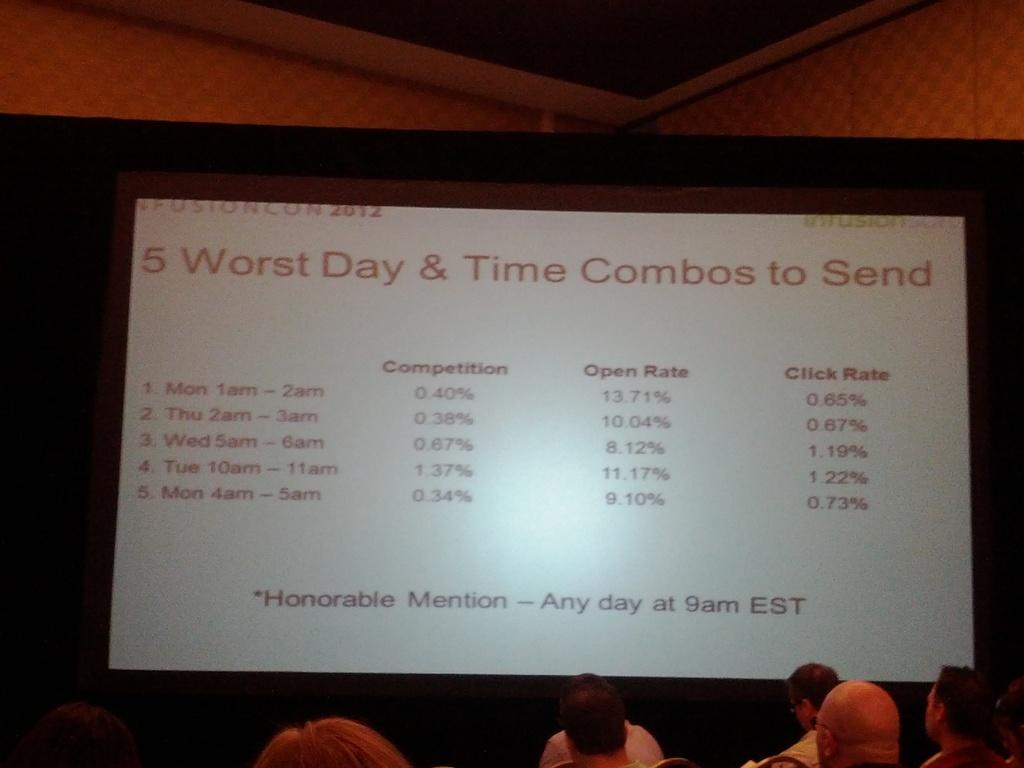What are the people in the image doing? The people in the image are sitting. What can be seen on the screen in the background of the image? There is a screen displaying text in the background of the image. How many eggs are being carried by the bee in the image? There is no bee or eggs present in the image. 